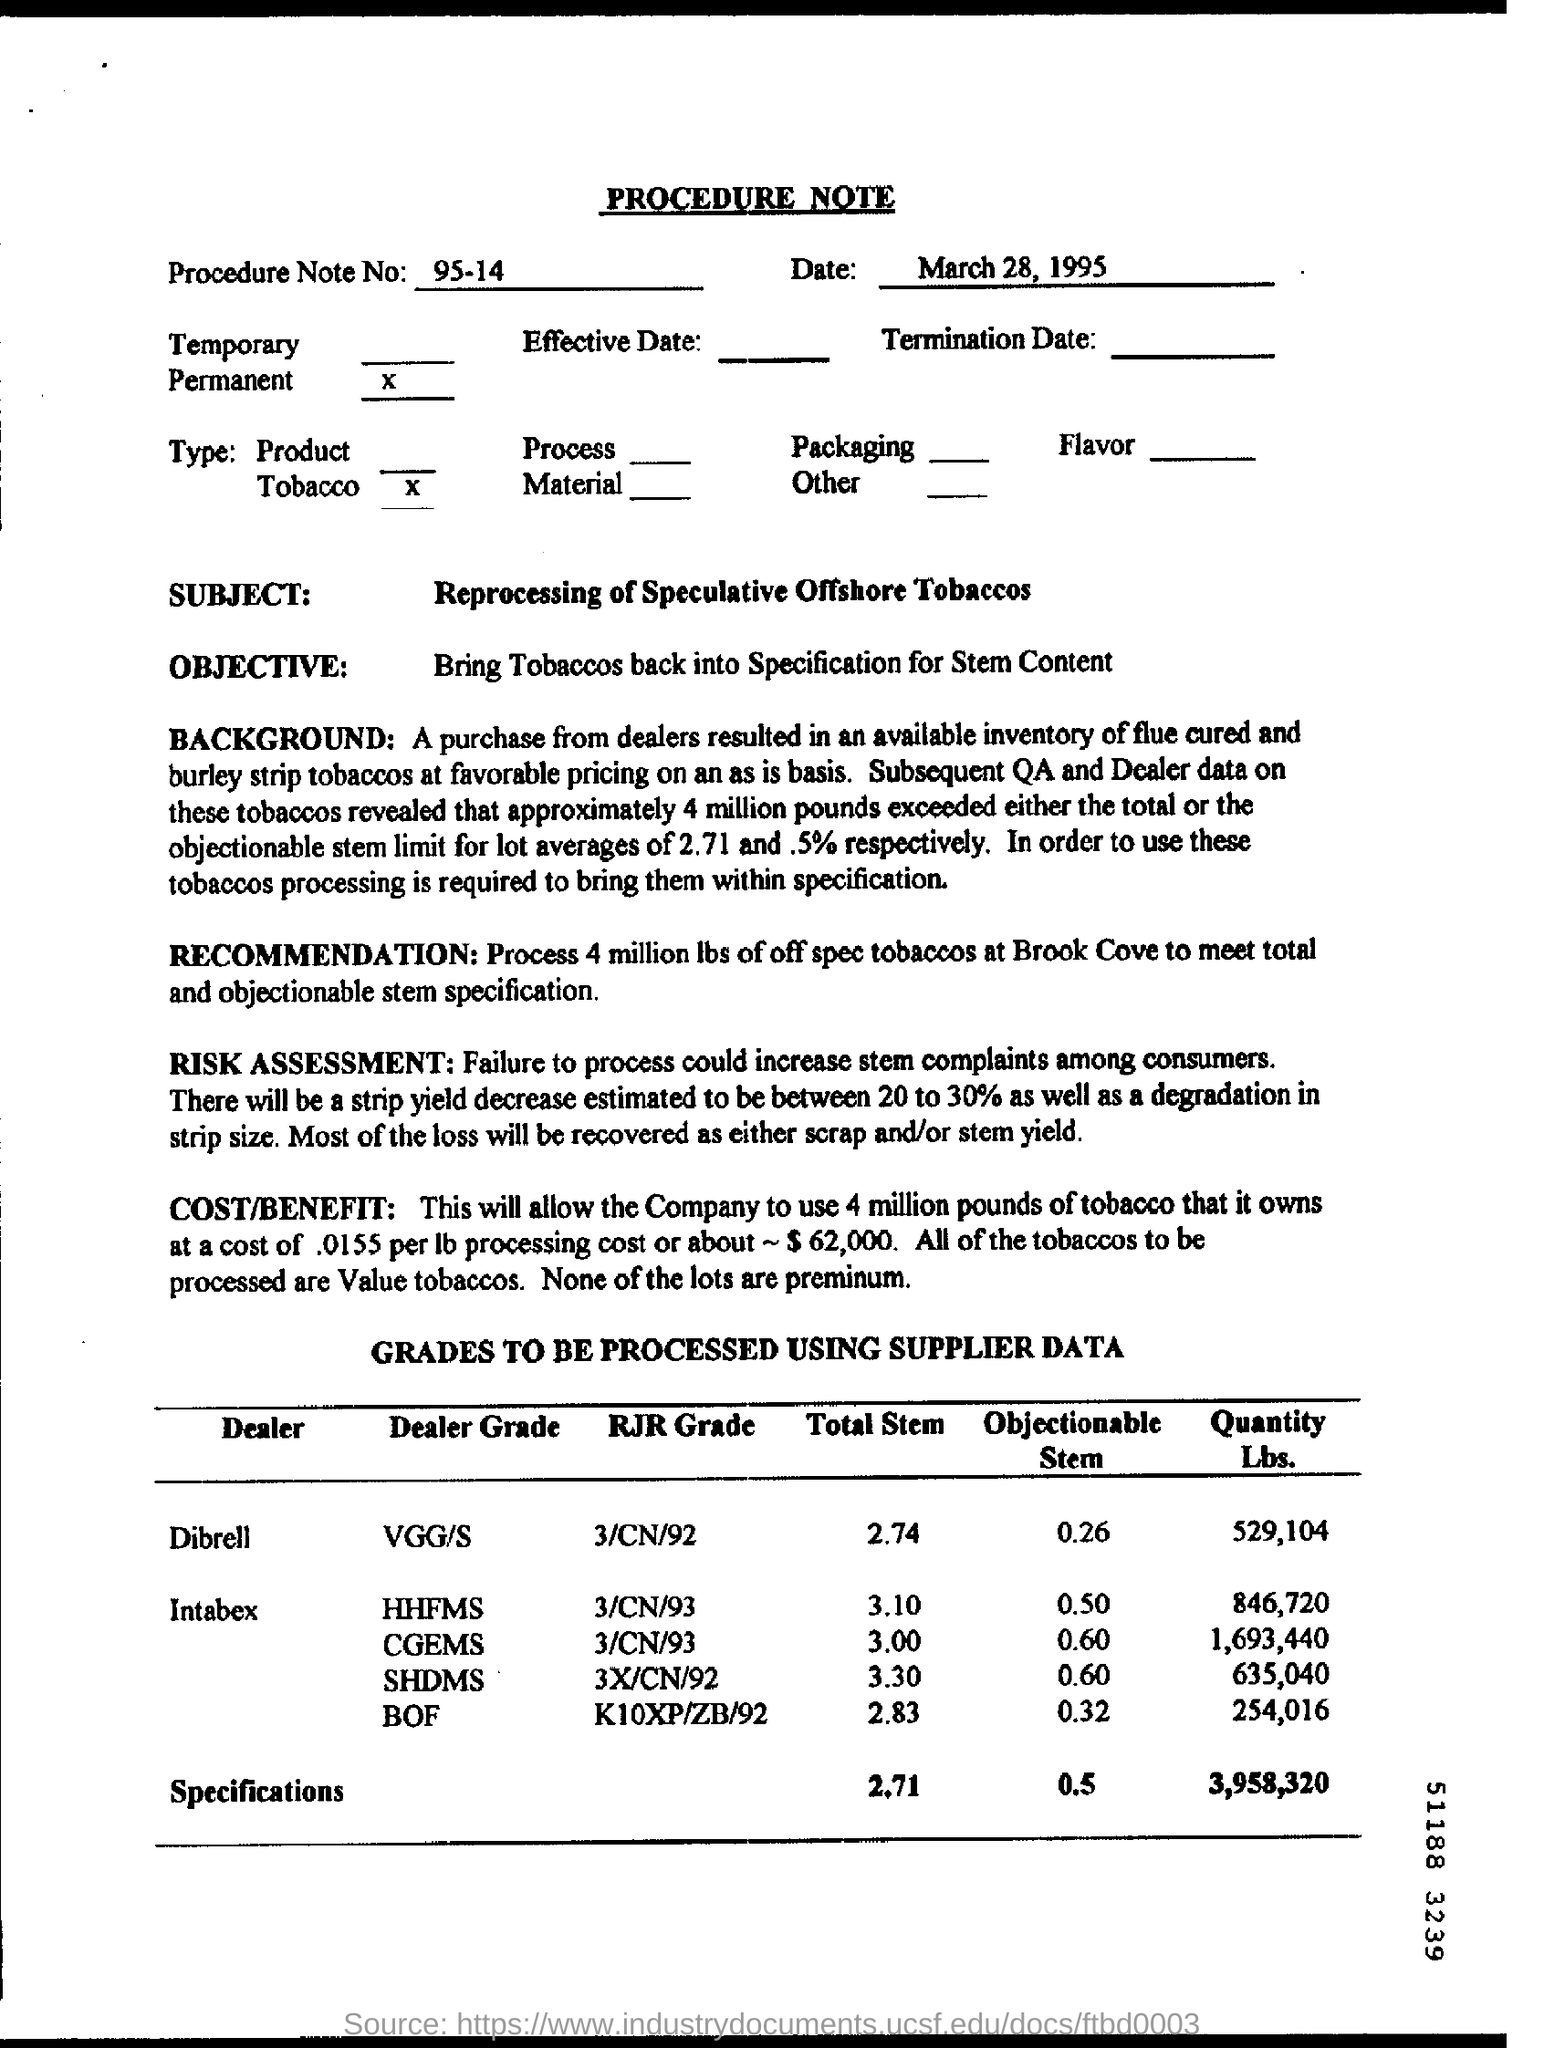What is the Procedure Note No. ?
 95-14 